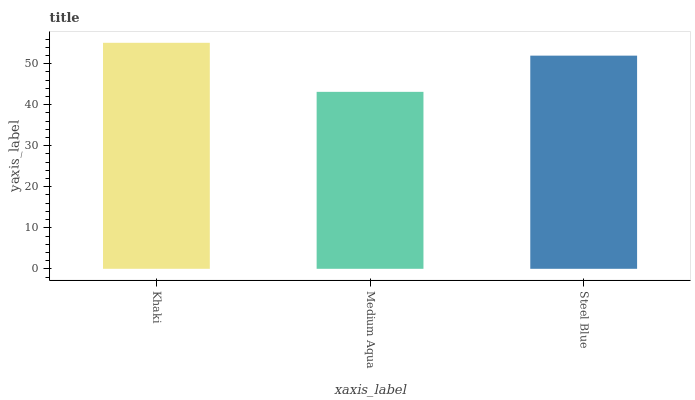Is Steel Blue the minimum?
Answer yes or no. No. Is Steel Blue the maximum?
Answer yes or no. No. Is Steel Blue greater than Medium Aqua?
Answer yes or no. Yes. Is Medium Aqua less than Steel Blue?
Answer yes or no. Yes. Is Medium Aqua greater than Steel Blue?
Answer yes or no. No. Is Steel Blue less than Medium Aqua?
Answer yes or no. No. Is Steel Blue the high median?
Answer yes or no. Yes. Is Steel Blue the low median?
Answer yes or no. Yes. Is Khaki the high median?
Answer yes or no. No. Is Khaki the low median?
Answer yes or no. No. 